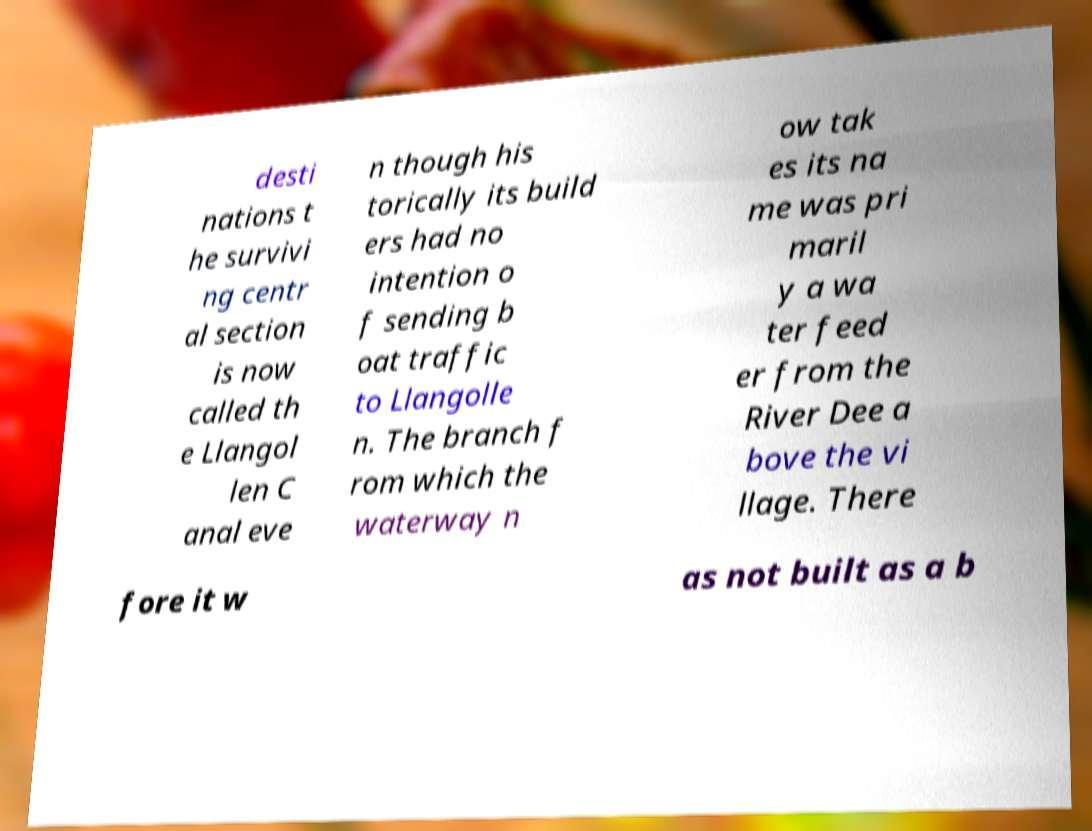I need the written content from this picture converted into text. Can you do that? desti nations t he survivi ng centr al section is now called th e Llangol len C anal eve n though his torically its build ers had no intention o f sending b oat traffic to Llangolle n. The branch f rom which the waterway n ow tak es its na me was pri maril y a wa ter feed er from the River Dee a bove the vi llage. There fore it w as not built as a b 